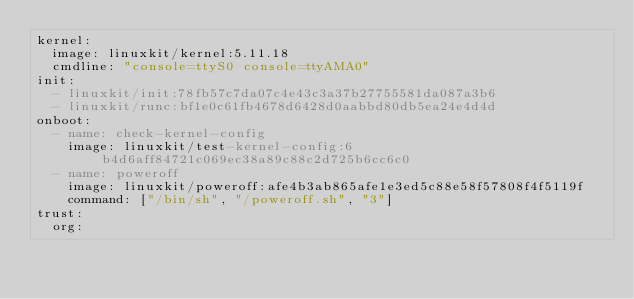Convert code to text. <code><loc_0><loc_0><loc_500><loc_500><_YAML_>kernel:
  image: linuxkit/kernel:5.11.18
  cmdline: "console=ttyS0 console=ttyAMA0"
init:
  - linuxkit/init:78fb57c7da07c4e43c3a37b27755581da087a3b6
  - linuxkit/runc:bf1e0c61fb4678d6428d0aabbd80db5ea24e4d4d
onboot:
  - name: check-kernel-config
    image: linuxkit/test-kernel-config:6b4d6aff84721c069ec38a89c88c2d725b6cc6c0
  - name: poweroff
    image: linuxkit/poweroff:afe4b3ab865afe1e3ed5c88e58f57808f4f5119f
    command: ["/bin/sh", "/poweroff.sh", "3"]
trust:
  org:</code> 